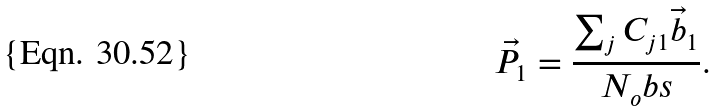<formula> <loc_0><loc_0><loc_500><loc_500>\vec { P } _ { 1 } = \frac { \sum _ { j } C _ { j 1 } \vec { b } _ { 1 } } { N _ { o } b s } .</formula> 